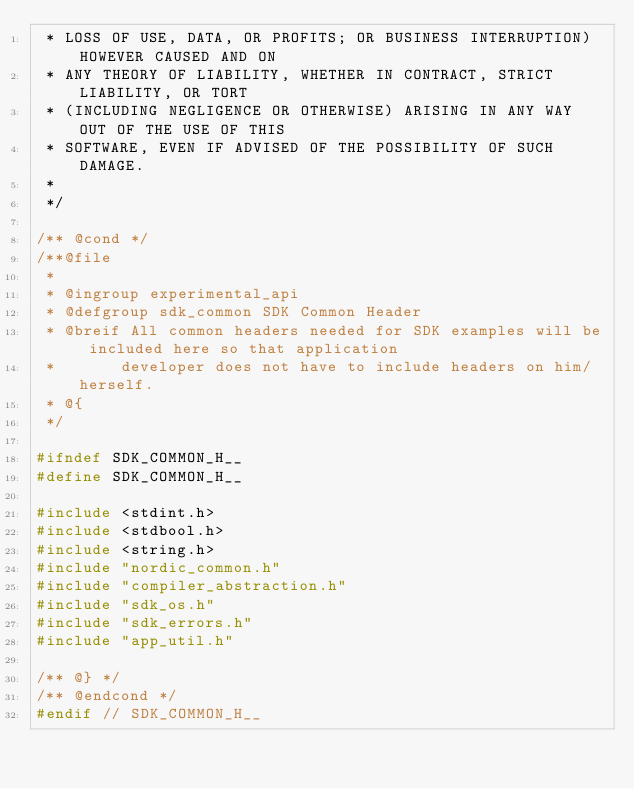Convert code to text. <code><loc_0><loc_0><loc_500><loc_500><_C_> * LOSS OF USE, DATA, OR PROFITS; OR BUSINESS INTERRUPTION) HOWEVER CAUSED AND ON
 * ANY THEORY OF LIABILITY, WHETHER IN CONTRACT, STRICT LIABILITY, OR TORT
 * (INCLUDING NEGLIGENCE OR OTHERWISE) ARISING IN ANY WAY OUT OF THE USE OF THIS
 * SOFTWARE, EVEN IF ADVISED OF THE POSSIBILITY OF SUCH DAMAGE.
 *
 */

/** @cond */
/**@file
 *
 * @ingroup experimental_api
 * @defgroup sdk_common SDK Common Header
 * @breif All common headers needed for SDK examples will be included here so that application
 *       developer does not have to include headers on him/herself.
 * @{
 */

#ifndef SDK_COMMON_H__
#define SDK_COMMON_H__

#include <stdint.h>
#include <stdbool.h>
#include <string.h>
#include "nordic_common.h"
#include "compiler_abstraction.h"
#include "sdk_os.h"
#include "sdk_errors.h"
#include "app_util.h"

/** @} */
/** @endcond */
#endif // SDK_COMMON_H__
</code> 